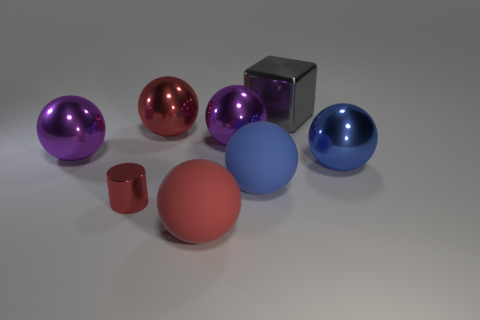How many things are either shiny objects on the right side of the large gray cube or big blue metallic spheres?
Keep it short and to the point. 1. How many big yellow cubes are there?
Offer a very short reply. 0. There is a red thing that is the same material as the tiny red cylinder; what shape is it?
Your answer should be compact. Sphere. There is a blue thing that is in front of the large blue ball to the right of the big cube; how big is it?
Keep it short and to the point. Large. What number of things are either blue balls that are in front of the blue shiny sphere or balls that are on the left side of the big gray thing?
Give a very brief answer. 5. Are there fewer large blue rubber objects than brown rubber blocks?
Your response must be concise. No. What number of things are large blue rubber blocks or large rubber spheres?
Ensure brevity in your answer.  2. Is the shape of the small red thing the same as the large red shiny object?
Ensure brevity in your answer.  No. There is a object that is on the right side of the cube; is its size the same as the purple object that is to the right of the tiny red thing?
Provide a short and direct response. Yes. There is a large thing that is both in front of the blue metal sphere and behind the red metallic cylinder; what material is it?
Your response must be concise. Rubber. 